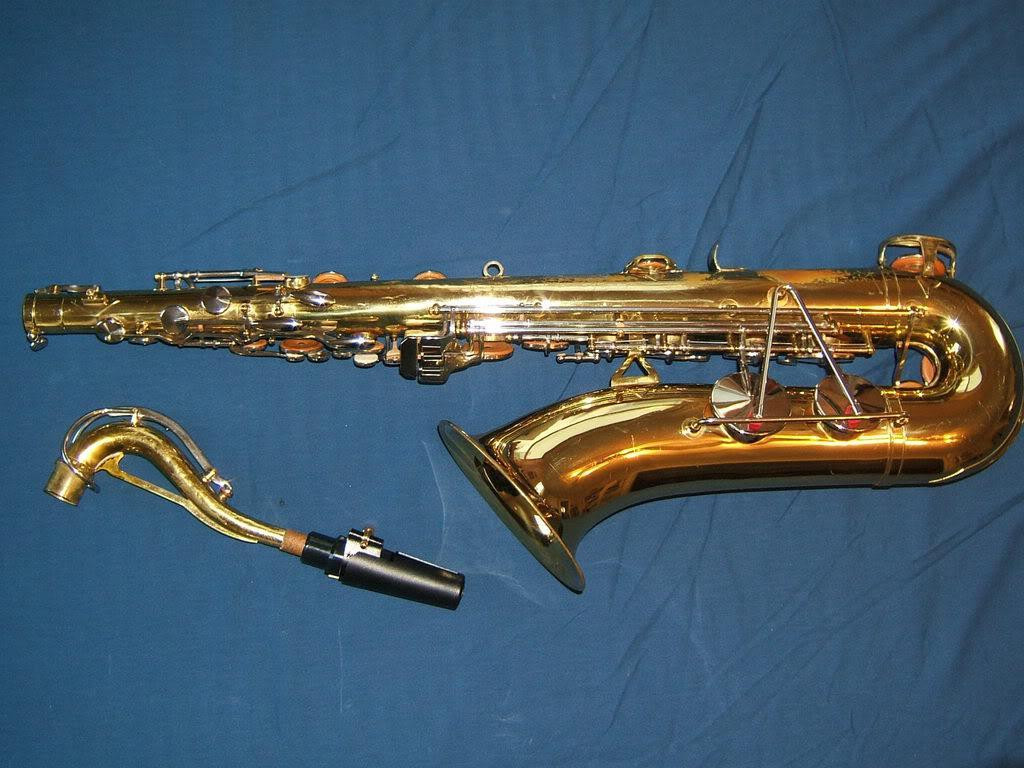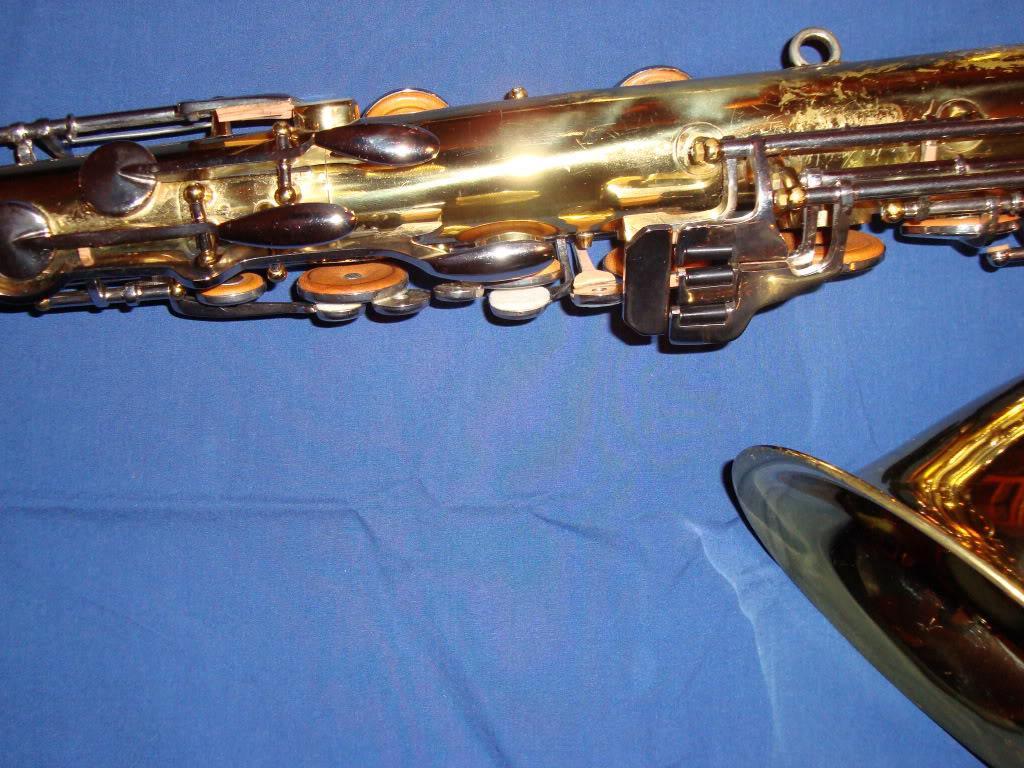The first image is the image on the left, the second image is the image on the right. Considering the images on both sides, is "There is an image of a saxophone with its neck removed from the body of the instrument." valid? Answer yes or no. Yes. 